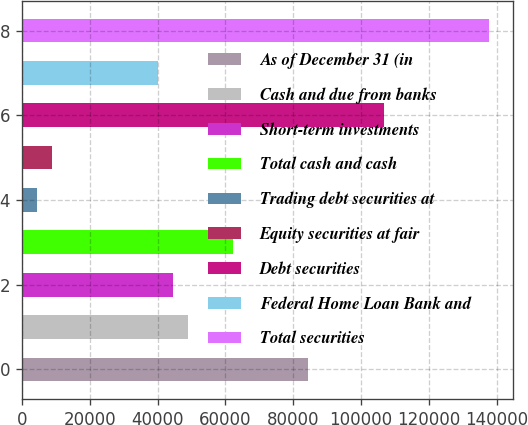Convert chart to OTSL. <chart><loc_0><loc_0><loc_500><loc_500><bar_chart><fcel>As of December 31 (in<fcel>Cash and due from banks<fcel>Short-term investments<fcel>Total cash and cash<fcel>Trading debt securities at<fcel>Equity securities at fair<fcel>Debt securities<fcel>Federal Home Loan Bank and<fcel>Total securities<nl><fcel>84457.5<fcel>48898.3<fcel>44453.4<fcel>62233<fcel>4449.3<fcel>8894.2<fcel>106682<fcel>40008.5<fcel>137796<nl></chart> 